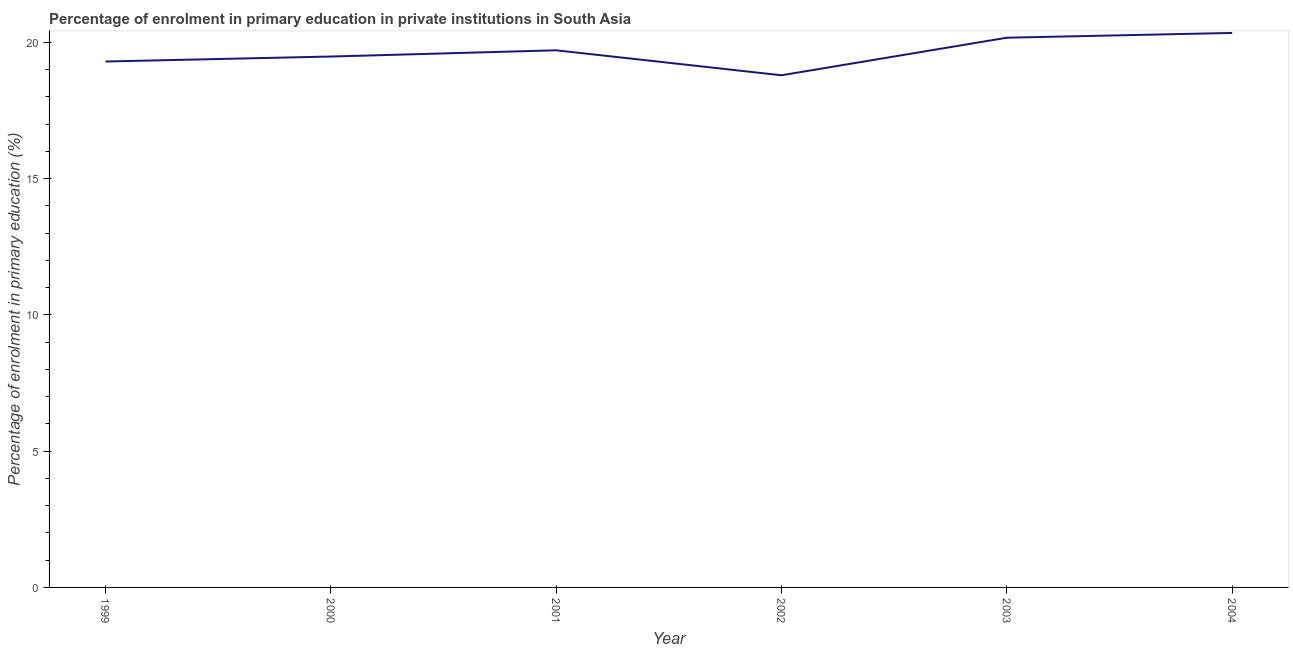What is the enrolment percentage in primary education in 2002?
Keep it short and to the point. 18.79. Across all years, what is the maximum enrolment percentage in primary education?
Provide a short and direct response. 20.35. Across all years, what is the minimum enrolment percentage in primary education?
Provide a succinct answer. 18.79. In which year was the enrolment percentage in primary education maximum?
Ensure brevity in your answer.  2004. What is the sum of the enrolment percentage in primary education?
Keep it short and to the point. 117.81. What is the difference between the enrolment percentage in primary education in 1999 and 2002?
Provide a succinct answer. 0.5. What is the average enrolment percentage in primary education per year?
Your answer should be compact. 19.63. What is the median enrolment percentage in primary education?
Your response must be concise. 19.6. What is the ratio of the enrolment percentage in primary education in 1999 to that in 2004?
Offer a very short reply. 0.95. Is the enrolment percentage in primary education in 2000 less than that in 2003?
Provide a short and direct response. Yes. Is the difference between the enrolment percentage in primary education in 1999 and 2001 greater than the difference between any two years?
Provide a short and direct response. No. What is the difference between the highest and the second highest enrolment percentage in primary education?
Your answer should be very brief. 0.17. Is the sum of the enrolment percentage in primary education in 1999 and 2002 greater than the maximum enrolment percentage in primary education across all years?
Ensure brevity in your answer.  Yes. What is the difference between the highest and the lowest enrolment percentage in primary education?
Keep it short and to the point. 1.55. In how many years, is the enrolment percentage in primary education greater than the average enrolment percentage in primary education taken over all years?
Offer a very short reply. 3. Does the enrolment percentage in primary education monotonically increase over the years?
Ensure brevity in your answer.  No. What is the difference between two consecutive major ticks on the Y-axis?
Provide a succinct answer. 5. Does the graph contain grids?
Offer a very short reply. No. What is the title of the graph?
Ensure brevity in your answer.  Percentage of enrolment in primary education in private institutions in South Asia. What is the label or title of the X-axis?
Give a very brief answer. Year. What is the label or title of the Y-axis?
Provide a short and direct response. Percentage of enrolment in primary education (%). What is the Percentage of enrolment in primary education (%) in 1999?
Give a very brief answer. 19.3. What is the Percentage of enrolment in primary education (%) of 2000?
Offer a terse response. 19.48. What is the Percentage of enrolment in primary education (%) of 2001?
Provide a short and direct response. 19.71. What is the Percentage of enrolment in primary education (%) in 2002?
Your answer should be compact. 18.79. What is the Percentage of enrolment in primary education (%) in 2003?
Give a very brief answer. 20.17. What is the Percentage of enrolment in primary education (%) in 2004?
Keep it short and to the point. 20.35. What is the difference between the Percentage of enrolment in primary education (%) in 1999 and 2000?
Give a very brief answer. -0.18. What is the difference between the Percentage of enrolment in primary education (%) in 1999 and 2001?
Your response must be concise. -0.41. What is the difference between the Percentage of enrolment in primary education (%) in 1999 and 2002?
Make the answer very short. 0.5. What is the difference between the Percentage of enrolment in primary education (%) in 1999 and 2003?
Your answer should be very brief. -0.87. What is the difference between the Percentage of enrolment in primary education (%) in 1999 and 2004?
Offer a very short reply. -1.05. What is the difference between the Percentage of enrolment in primary education (%) in 2000 and 2001?
Provide a short and direct response. -0.23. What is the difference between the Percentage of enrolment in primary education (%) in 2000 and 2002?
Your response must be concise. 0.69. What is the difference between the Percentage of enrolment in primary education (%) in 2000 and 2003?
Your response must be concise. -0.69. What is the difference between the Percentage of enrolment in primary education (%) in 2000 and 2004?
Your answer should be compact. -0.87. What is the difference between the Percentage of enrolment in primary education (%) in 2001 and 2002?
Ensure brevity in your answer.  0.92. What is the difference between the Percentage of enrolment in primary education (%) in 2001 and 2003?
Give a very brief answer. -0.46. What is the difference between the Percentage of enrolment in primary education (%) in 2001 and 2004?
Provide a short and direct response. -0.64. What is the difference between the Percentage of enrolment in primary education (%) in 2002 and 2003?
Your response must be concise. -1.38. What is the difference between the Percentage of enrolment in primary education (%) in 2002 and 2004?
Offer a very short reply. -1.55. What is the difference between the Percentage of enrolment in primary education (%) in 2003 and 2004?
Keep it short and to the point. -0.17. What is the ratio of the Percentage of enrolment in primary education (%) in 1999 to that in 2000?
Offer a very short reply. 0.99. What is the ratio of the Percentage of enrolment in primary education (%) in 1999 to that in 2004?
Your answer should be very brief. 0.95. What is the ratio of the Percentage of enrolment in primary education (%) in 2000 to that in 2001?
Provide a short and direct response. 0.99. What is the ratio of the Percentage of enrolment in primary education (%) in 2000 to that in 2002?
Your answer should be compact. 1.04. What is the ratio of the Percentage of enrolment in primary education (%) in 2001 to that in 2002?
Ensure brevity in your answer.  1.05. What is the ratio of the Percentage of enrolment in primary education (%) in 2001 to that in 2003?
Your answer should be compact. 0.98. What is the ratio of the Percentage of enrolment in primary education (%) in 2002 to that in 2003?
Provide a succinct answer. 0.93. What is the ratio of the Percentage of enrolment in primary education (%) in 2002 to that in 2004?
Your answer should be compact. 0.92. What is the ratio of the Percentage of enrolment in primary education (%) in 2003 to that in 2004?
Give a very brief answer. 0.99. 